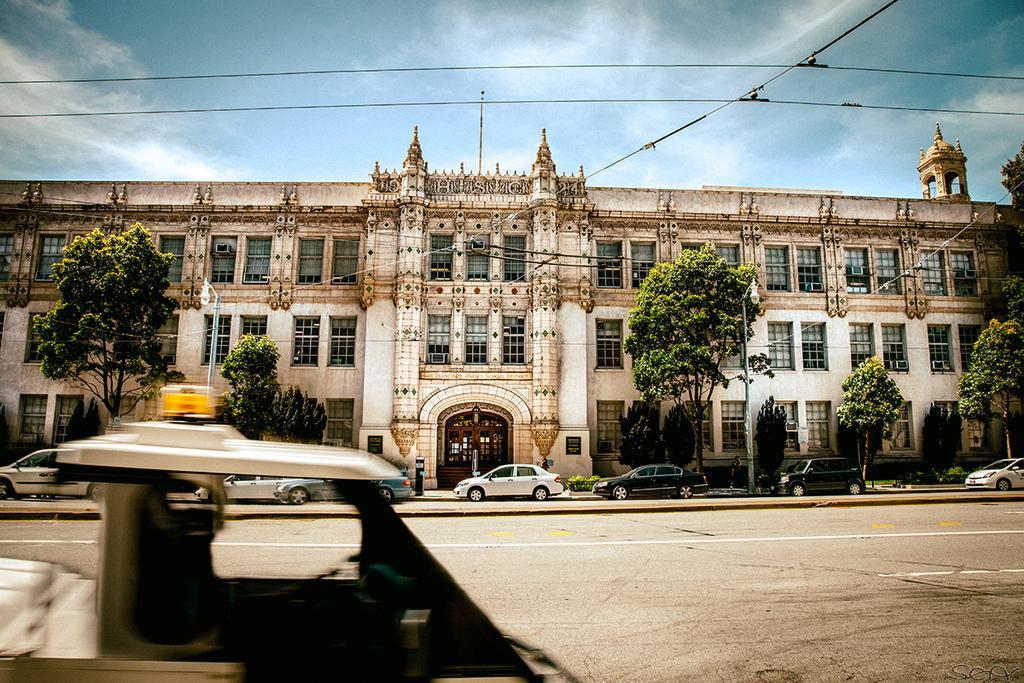Could you give a brief overview of what you see in this image? There is road. On the road there are vehicles. In the back there is a building with windows. There are street light poles. In the background there is sky with clouds. 